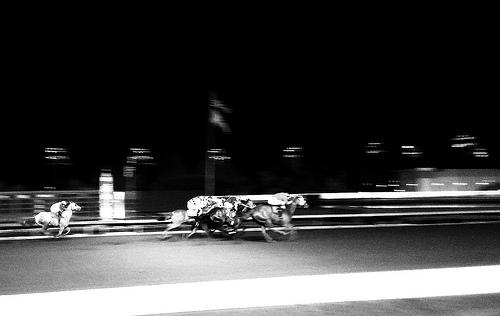Provide a brief description of how the people in the image are positioned. The jockeys are bent over on top of the racing horses, assuming a crouched position to maintain balance during the race. State the appearance of lighting in the picture. The image has artificial lighting shining from blurry lights at night and on the ground, providing a luminous effect. Describe the surface on which the race is taking place. The race is taking place on a grey dirt track with a wide white line running across it. Mention the key feature of the jockeys' attire in the image. A key feature of the jockeys' attire is the white hat worn on top. Mention the prominent object and its related action in the given image. The prominent object is horses, and they are participating in a race on a track. Analyze the condition of the environment surrounding the horses. The environment is a racetrack with grey dirt, a wide white line, fences on the side, blurred lights lining the track, and flags flying on a pole. Estimate the number of horses involved in the race. There are at least four horses involved in the race. Identify the primary activity taking place in the image. Horses racing on a track with jockeys on their backs, competing against each other. What type of image is this, and what is the main focus of the photograph? This is a black and white photograph, with the main focus being horses racing down a track with jockeys on top. What type of animal is in motion in the image? Horses are in motion, racing down a track. Is the image in black and white or in color? The image is in black and white. Can you find the colorful balloons floating in the sky? The image is in black and white, making it impossible for there to be colorful balloons. Identify the condition of the sky in the image. The sky is black and dark. Identify the jockey wearing a white hat. The jockey wearing a white hat is at position X:56 Y:198, Width:13 Height:13. What is the position of the legs of the horse in motion? Front legs (X:55 Y:221, Width:11 Height:11), back legs (X:36 Y:222, Width:15 Height:15). List all the objects detected in the image with their respective positions. Horses (X:30 Y:192, Width:280 Height:280), flags on pole (X:206 Y:89, Width:25 Height:25), lights (X:44 Y:135, Width:449 Height:449), dirt track (X:12 Y:222, Width:479 Height:479), fence (X:0 Y:183, Width:142 Height:142). Observe the people standing by the sidelines cheering for the horses. The image does not show or mention any people standing by the sidelines, just horses, jockeys, and track elements such as flags and fences. Is the horse racing track in a straight line or a curve? The horse racing track appears to be mostly straight with a slight curve. Which direction are the horses running? The horses are running to the right. Describe the interaction between the horses and the flags. The flags are flying behind the horses as they race down the track. Spot the camera crew and microphone stationed near the track to capture the event. The image contains no reference to a camera crew, microphone, or any media presence related to covering the event, making this instruction entirely misleading. Evaluate the quality of the image based on its clarity. The image has a mix of clarity and blurriness, especially around the light sources. There is a large tree casting a shadow on one side of the track. None of the image's information and captions include a tree or shadows, making it unlikely that there is a tree in the image. What objects are the horses and riders near? The horses and riders are near a fence, a dirt track, and flying flags. Identify the car parked near the fence on the edge of the racetrack. No, it's not mentioned in the image. Where is the light shining in the image? The light is shining on the ground and the horses. What do the blurry lights in the image represent? The blurry lights represent artificial light sources lining the horse track. How many flags are flying in the image? There are two flags flying in the image. How would you rate the overall sharpness of the image? The overall sharpness of the image is average. What unique attribute does the jockey on the horse in the rear have? The jockey on the horse in the rear is wearing a white hat. Is the tail of a horse in the image black or brown? The tail of the horse is black. What type of event is occurring in the image? A horse race is taking place. Can you locate a big clock showing the race time in the background? The image's information and captions do not mention any clock or race time, so it is misleading to ask someone to search for those elements in the image. Describe the main subject in the image and its action. Horses are racing down a track with jockeys riding them. Is there an anomaly in the image involving a horse or a jockey? No, there is no anomaly involving a horse or a jockey. What is the position and size of the white horse in the image? The white horse is at position X:14 Y:190 with width: 75 and height: 75. 